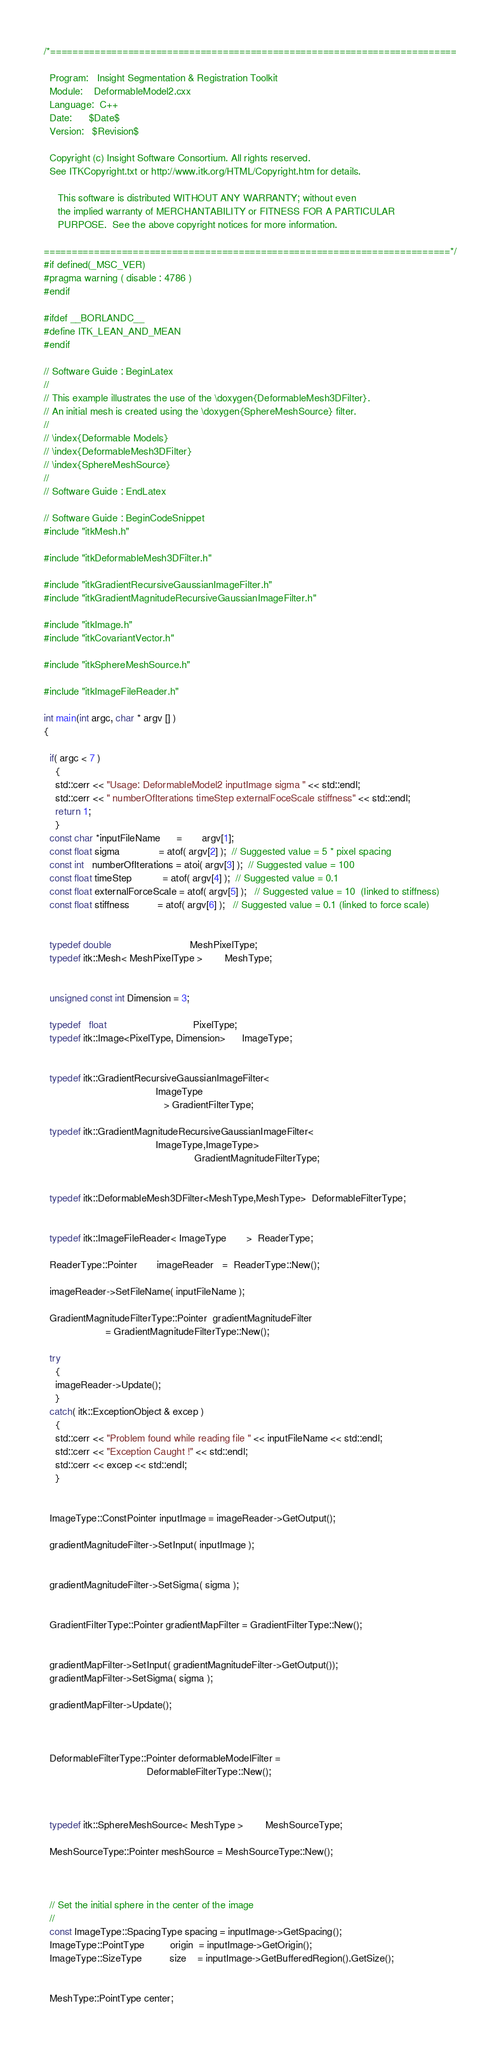<code> <loc_0><loc_0><loc_500><loc_500><_C++_>/*=========================================================================

  Program:   Insight Segmentation & Registration Toolkit
  Module:    DeformableModel2.cxx
  Language:  C++
  Date:      $Date$
  Version:   $Revision$

  Copyright (c) Insight Software Consortium. All rights reserved.
  See ITKCopyright.txt or http://www.itk.org/HTML/Copyright.htm for details.

     This software is distributed WITHOUT ANY WARRANTY; without even 
     the implied warranty of MERCHANTABILITY or FITNESS FOR A PARTICULAR 
     PURPOSE.  See the above copyright notices for more information.

=========================================================================*/
#if defined(_MSC_VER)
#pragma warning ( disable : 4786 )
#endif

#ifdef __BORLANDC__
#define ITK_LEAN_AND_MEAN
#endif

// Software Guide : BeginLatex
//
// This example illustrates the use of the \doxygen{DeformableMesh3DFilter}.
// An initial mesh is created using the \doxygen{SphereMeshSource} filter.
// 
// \index{Deformable Models}
// \index{DeformableMesh3DFilter}
// \index{SphereMeshSource}
//
// Software Guide : EndLatex 

// Software Guide : BeginCodeSnippet
#include "itkMesh.h"

#include "itkDeformableMesh3DFilter.h" 

#include "itkGradientRecursiveGaussianImageFilter.h" 
#include "itkGradientMagnitudeRecursiveGaussianImageFilter.h" 

#include "itkImage.h"
#include "itkCovariantVector.h"

#include "itkSphereMeshSource.h"

#include "itkImageFileReader.h" 

int main(int argc, char * argv [] )
{

  if( argc < 7 )
    {
    std::cerr << "Usage: DeformableModel2 inputImage sigma " << std::endl;
    std::cerr << " numberOfIterations timeStep externalFoceScale stiffness" << std::endl;
    return 1;
    }
  const char *inputFileName      =       argv[1];
  const float sigma              = atof( argv[2] );  // Suggested value = 5 * pixel spacing
  const int   numberOfIterations = atoi( argv[3] );  // Suggested value = 100
  const float timeStep           = atof( argv[4] );  // Suggested value = 0.1
  const float externalForceScale = atof( argv[5] );   // Suggested value = 10  (linked to stiffness)
  const float stiffness          = atof( argv[6] );   // Suggested value = 0.1 (linked to force scale)
  

  typedef double                            MeshPixelType;
  typedef itk::Mesh< MeshPixelType >        MeshType;


  unsigned const int Dimension = 3;

  typedef   float                               PixelType;
  typedef itk::Image<PixelType, Dimension>      ImageType;

  
  typedef itk::GradientRecursiveGaussianImageFilter<
                                        ImageType
                                           > GradientFilterType;

  typedef itk::GradientMagnitudeRecursiveGaussianImageFilter<
                                        ImageType,ImageType>
                                                      GradientMagnitudeFilterType;


  typedef itk::DeformableMesh3DFilter<MeshType,MeshType>  DeformableFilterType;
  
    
  typedef itk::ImageFileReader< ImageType       >  ReaderType;

  ReaderType::Pointer       imageReader   =  ReaderType::New();

  imageReader->SetFileName( inputFileName );

  GradientMagnitudeFilterType::Pointer  gradientMagnitudeFilter
                      = GradientMagnitudeFilterType::New();

  try
    {
    imageReader->Update();
    }
  catch( itk::ExceptionObject & excep )
    {
    std::cerr << "Problem found while reading file " << inputFileName << std::endl;
    std::cerr << "Exception Caught !" << std::endl;
    std::cerr << excep << std::endl;
    }


  ImageType::ConstPointer inputImage = imageReader->GetOutput();

  gradientMagnitudeFilter->SetInput( inputImage ); 


  gradientMagnitudeFilter->SetSigma( sigma );


  GradientFilterType::Pointer gradientMapFilter = GradientFilterType::New();


  gradientMapFilter->SetInput( gradientMagnitudeFilter->GetOutput());
  gradientMapFilter->SetSigma( sigma );
  
  gradientMapFilter->Update();
  

  
  DeformableFilterType::Pointer deformableModelFilter = 
                                     DeformableFilterType::New();


  
  typedef itk::SphereMeshSource< MeshType >        MeshSourceType;

  MeshSourceType::Pointer meshSource = MeshSourceType::New();
  


  // Set the initial sphere in the center of the image
  //
  const ImageType::SpacingType spacing = inputImage->GetSpacing();
  ImageType::PointType         origin  = inputImage->GetOrigin();
  ImageType::SizeType          size    = inputImage->GetBufferedRegion().GetSize();

  
  MeshType::PointType center;</code> 